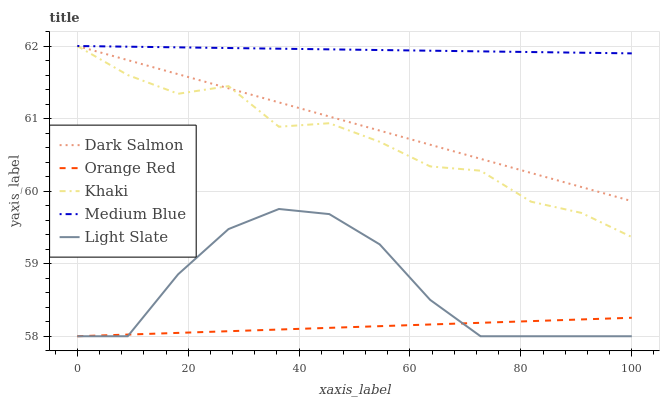Does Orange Red have the minimum area under the curve?
Answer yes or no. Yes. Does Medium Blue have the maximum area under the curve?
Answer yes or no. Yes. Does Khaki have the minimum area under the curve?
Answer yes or no. No. Does Khaki have the maximum area under the curve?
Answer yes or no. No. Is Orange Red the smoothest?
Answer yes or no. Yes. Is Khaki the roughest?
Answer yes or no. Yes. Is Medium Blue the smoothest?
Answer yes or no. No. Is Medium Blue the roughest?
Answer yes or no. No. Does Khaki have the lowest value?
Answer yes or no. No. Does Dark Salmon have the highest value?
Answer yes or no. Yes. Does Orange Red have the highest value?
Answer yes or no. No. Is Orange Red less than Medium Blue?
Answer yes or no. Yes. Is Medium Blue greater than Orange Red?
Answer yes or no. Yes. Does Khaki intersect Dark Salmon?
Answer yes or no. Yes. Is Khaki less than Dark Salmon?
Answer yes or no. No. Is Khaki greater than Dark Salmon?
Answer yes or no. No. Does Orange Red intersect Medium Blue?
Answer yes or no. No. 